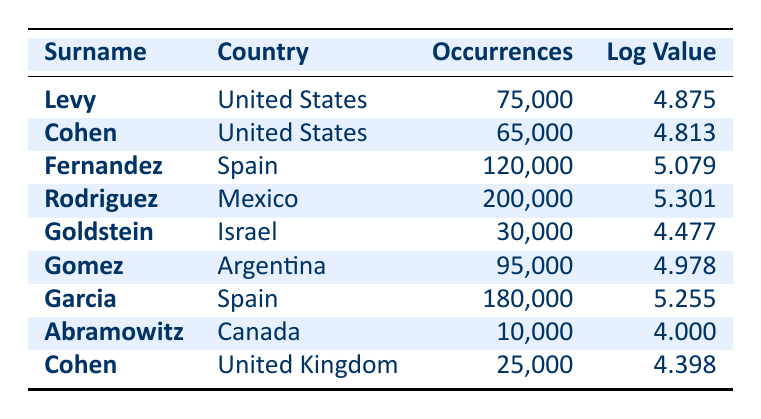What is the highest number of occurrences of a surname in the table? The surname with the highest occurrences is "Rodriguez," recorded in Mexico with 200,000 occurrences. By scanning the occurrences in the table, I identify Rodriguez has the highest value.
Answer: 200000 Which surname has the lowest logarithmic value? The surname with the lowest logarithmic value is "Abramowitz," listed in Canada, with a logarithmic value of 4.000. I find the logarithmic values in the table and see that Abramowitz has the smallest value.
Answer: 4.000 How many more occurrences does "Garcia" have than "Cohen" in the United Kingdom? "Garcia" has 180,000 occurrences, while "Cohen" in the UK has 25,000. The difference is calculated as 180,000 - 25,000, which equals 155,000.
Answer: 155000 Is "Goldstein" more common than "Gomez"? "Goldstein" has 30,000 occurrences, and "Gomez" has 95,000 occurrences. Since 30,000 is less than 95,000, the answer is no. I compare the occurrences and conclude that Goldstein is not more common.
Answer: No What is the average number of occurrences for the surnames listed from Spain? The surnames from Spain are "Fernandez" with 120,000 and "Garcia" with 180,000. The average is calculated as (120,000 + 180,000) / 2 = 150,000. I find the occurrences for both surnames, sum them, and divide by 2 for the average.
Answer: 150000 Which country has the largest distribution of surnames in this dataset? The country with the largest distribution of surnames is Mexico, with "Rodriguez" having 200,000 occurrences. I scan through the countries and their occurrences, finding that none surpass that number.
Answer: Mexico How many surnames have occurrences greater than 70,000? The surnames with occurrences greater than 70,000 are "Levy," "Fernandez," "Rodriguez," "Gomez," and "Garcia." I count these to find there are five surnames that fit this criterion.
Answer: 5 What is the total number of occurrences for all surnames listed? To calculate the total occurrences, I add up all the values: 75,000 + 65,000 + 120,000 + 200,000 + 30,000 + 95,000 + 180,000 + 10,000 + 25,000 = 680,000. I go through each occurrence from the table and find the sum.
Answer: 680000 